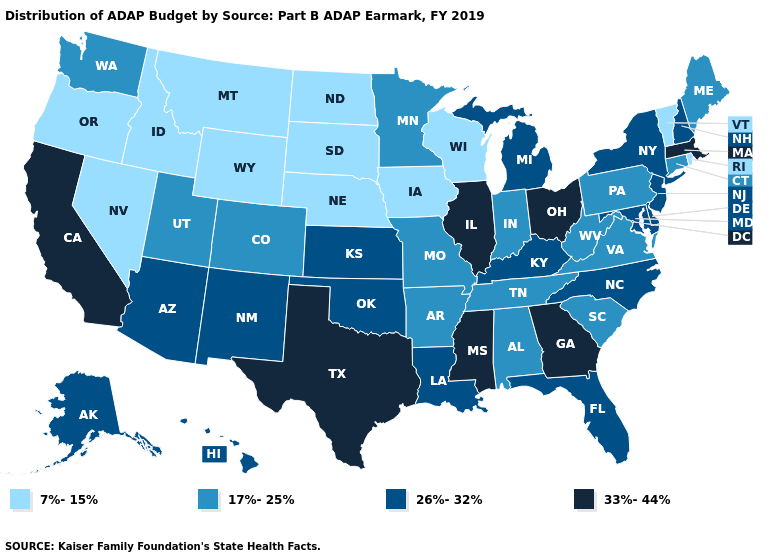Among the states that border Delaware , which have the lowest value?
Be succinct. Pennsylvania. Name the states that have a value in the range 7%-15%?
Concise answer only. Idaho, Iowa, Montana, Nebraska, Nevada, North Dakota, Oregon, Rhode Island, South Dakota, Vermont, Wisconsin, Wyoming. How many symbols are there in the legend?
Write a very short answer. 4. Name the states that have a value in the range 26%-32%?
Concise answer only. Alaska, Arizona, Delaware, Florida, Hawaii, Kansas, Kentucky, Louisiana, Maryland, Michigan, New Hampshire, New Jersey, New Mexico, New York, North Carolina, Oklahoma. Is the legend a continuous bar?
Give a very brief answer. No. Which states have the lowest value in the Northeast?
Be succinct. Rhode Island, Vermont. Name the states that have a value in the range 33%-44%?
Give a very brief answer. California, Georgia, Illinois, Massachusetts, Mississippi, Ohio, Texas. Name the states that have a value in the range 26%-32%?
Be succinct. Alaska, Arizona, Delaware, Florida, Hawaii, Kansas, Kentucky, Louisiana, Maryland, Michigan, New Hampshire, New Jersey, New Mexico, New York, North Carolina, Oklahoma. What is the value of South Carolina?
Concise answer only. 17%-25%. What is the value of Kansas?
Quick response, please. 26%-32%. Does Maine have a higher value than Idaho?
Keep it brief. Yes. What is the highest value in the Northeast ?
Answer briefly. 33%-44%. Does Wyoming have a higher value than Oregon?
Be succinct. No. Name the states that have a value in the range 7%-15%?
Be succinct. Idaho, Iowa, Montana, Nebraska, Nevada, North Dakota, Oregon, Rhode Island, South Dakota, Vermont, Wisconsin, Wyoming. Name the states that have a value in the range 7%-15%?
Concise answer only. Idaho, Iowa, Montana, Nebraska, Nevada, North Dakota, Oregon, Rhode Island, South Dakota, Vermont, Wisconsin, Wyoming. 